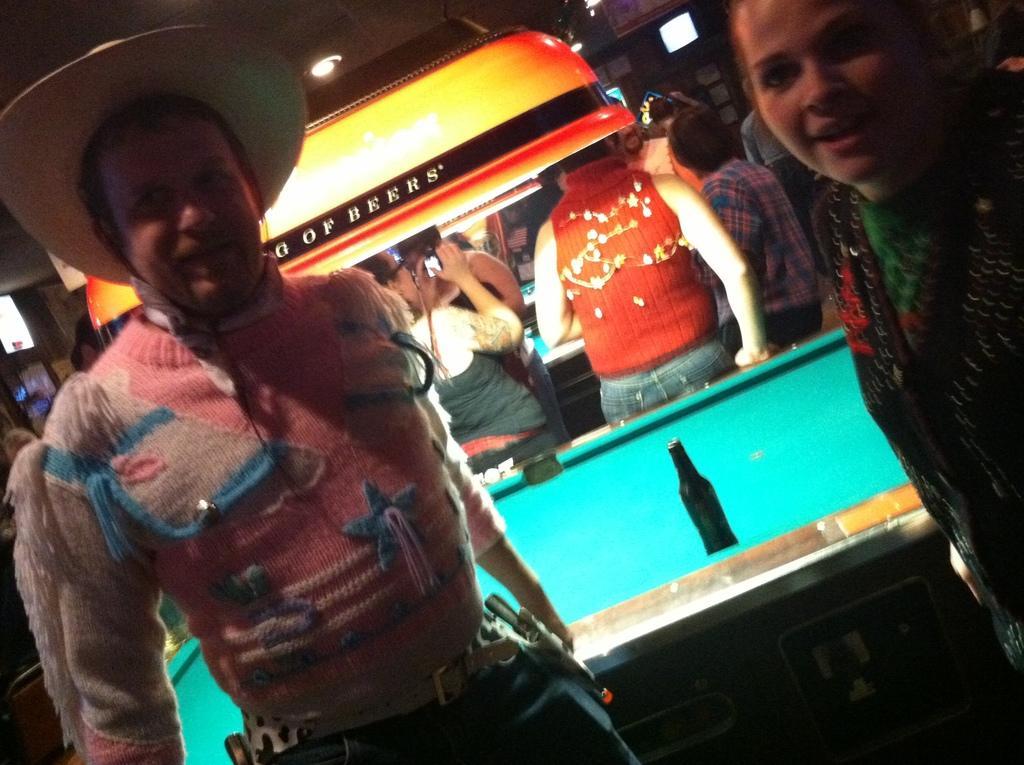How would you summarize this image in a sentence or two? As we can see in the image there is a light, few people here and there and a billiards board. On billiards board there is a bottle. 